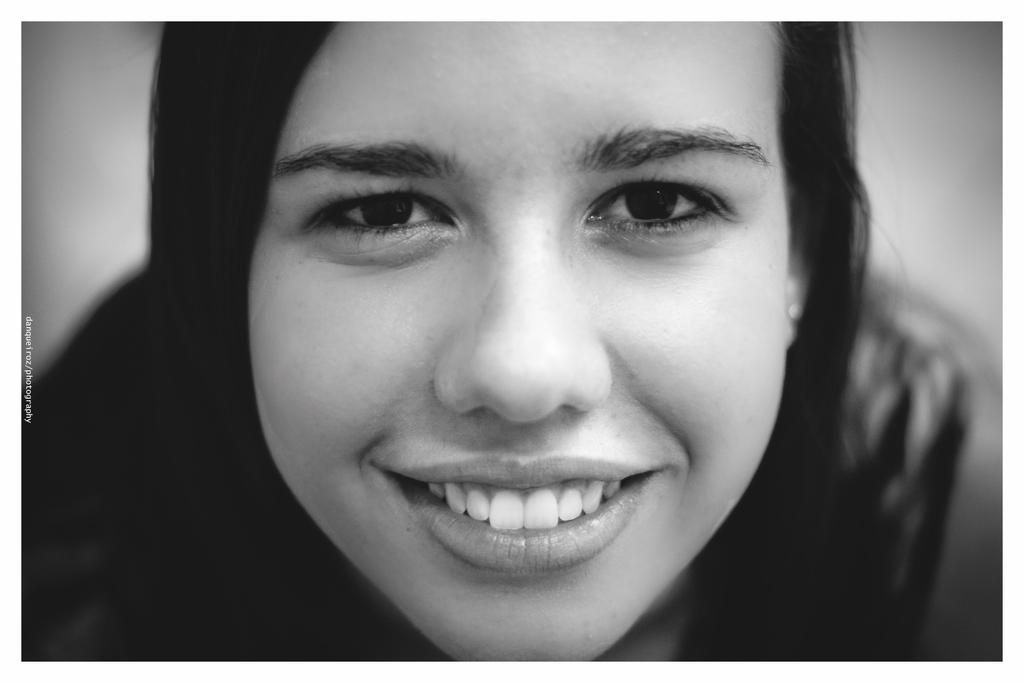Can you describe this image briefly? In this image a lady is sitting and smiling. 